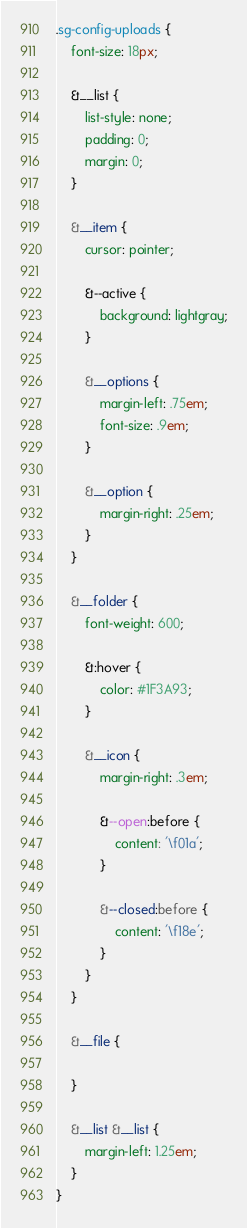Convert code to text. <code><loc_0><loc_0><loc_500><loc_500><_CSS_>.sg-config-uploads {
	font-size: 18px;
	
	&__list {
		list-style: none;
		padding: 0;
		margin: 0;
	}
	
	&__item {
		cursor: pointer;
		
		&--active {
			background: lightgray;
		}
		
		&__options {
			margin-left: .75em;
			font-size: .9em;
		}
		
		&__option {
			margin-right: .25em;
		}
	}
	
	&__folder {
		font-weight: 600;
		
		&:hover {
			color: #1F3A93;
		}
		
		&__icon {
			margin-right: .3em;
			
			&--open:before {
				content: '\f01a';
			}

			&--closed:before {
				content: '\f18e';
			}
		}
	}
	
	&__file {
		
	}
	
	&__list &__list {
		margin-left: 1.25em;
	}
}</code> 